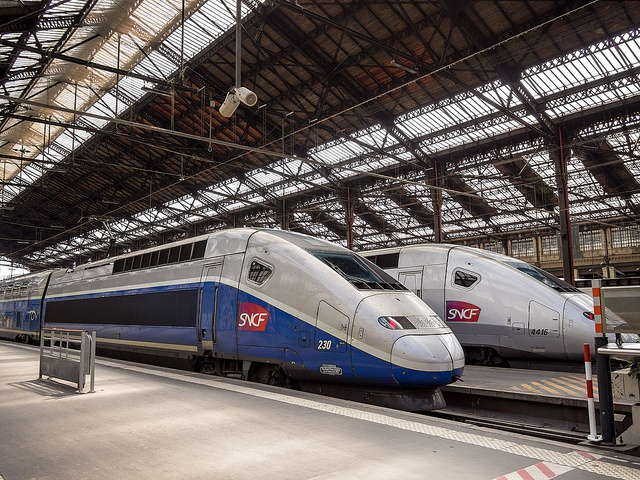Describe the objects in this image and their specific colors. I can see train in black, darkgray, navy, and gray tones and train in black, darkgray, gray, and lightgray tones in this image. 